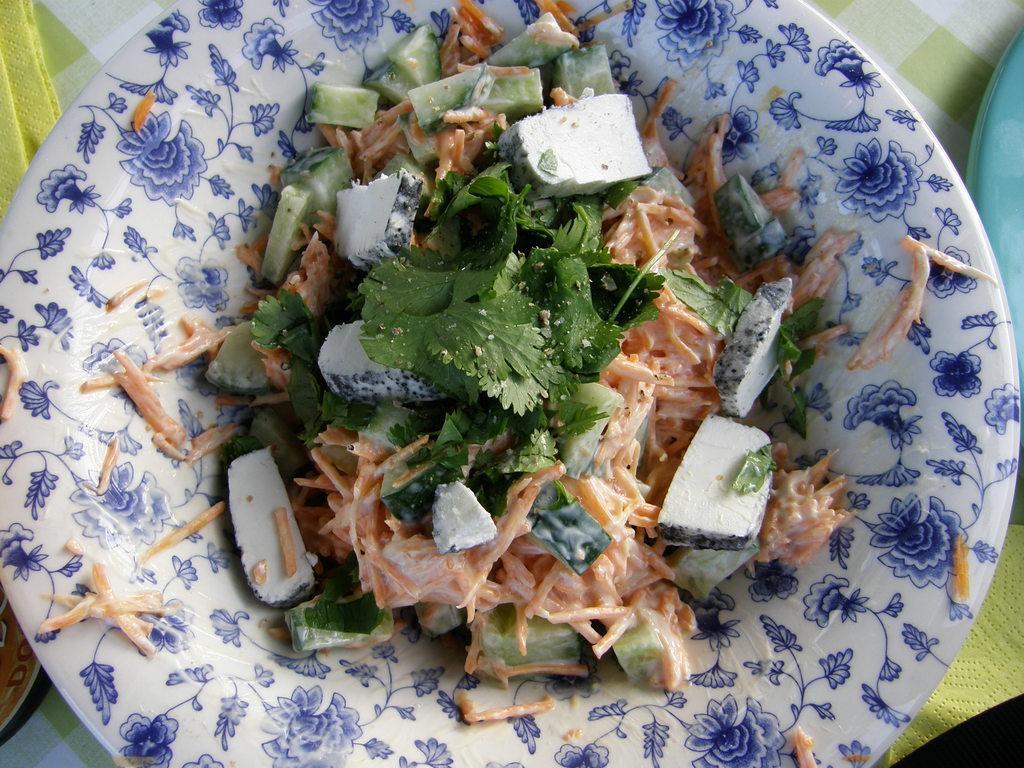How would you summarize this image in a sentence or two? In this picture I can see the mint, carrot and other vegetables pieces on a white plate. Beside that I can see the blue plate and cloth which is kept on the table. 